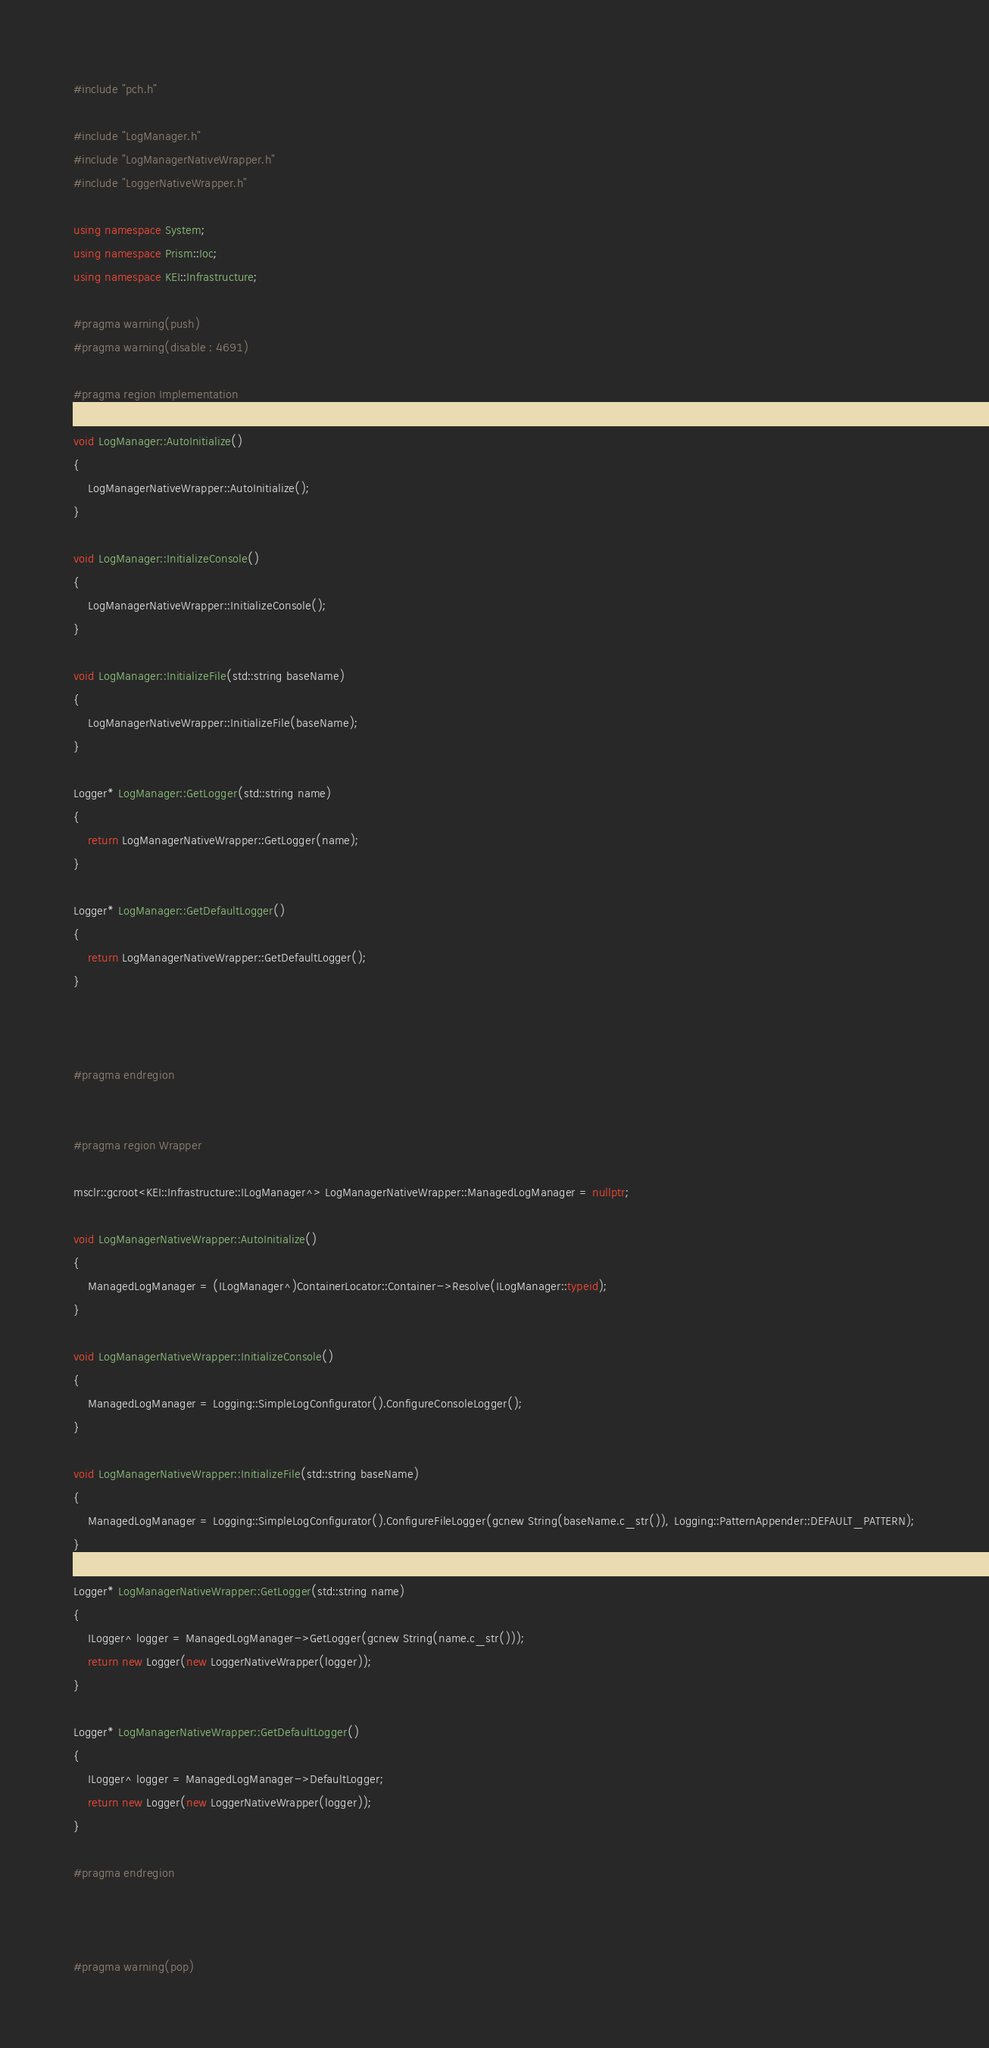Convert code to text. <code><loc_0><loc_0><loc_500><loc_500><_C++_>#include "pch.h"

#include "LogManager.h"
#include "LogManagerNativeWrapper.h"
#include "LoggerNativeWrapper.h"

using namespace System;
using namespace Prism::Ioc;
using namespace KEI::Infrastructure;

#pragma warning(push)
#pragma warning(disable : 4691)

#pragma region Implementation

void LogManager::AutoInitialize()
{
	LogManagerNativeWrapper::AutoInitialize();
}

void LogManager::InitializeConsole()
{
	LogManagerNativeWrapper::InitializeConsole();
}

void LogManager::InitializeFile(std::string baseName)
{
	LogManagerNativeWrapper::InitializeFile(baseName);
}

Logger* LogManager::GetLogger(std::string name)
{
	return LogManagerNativeWrapper::GetLogger(name);
}

Logger* LogManager::GetDefaultLogger()
{
	return LogManagerNativeWrapper::GetDefaultLogger();
}



#pragma endregion


#pragma region Wrapper

msclr::gcroot<KEI::Infrastructure::ILogManager^> LogManagerNativeWrapper::ManagedLogManager = nullptr;

void LogManagerNativeWrapper::AutoInitialize()
{
	ManagedLogManager = (ILogManager^)ContainerLocator::Container->Resolve(ILogManager::typeid);
}

void LogManagerNativeWrapper::InitializeConsole()
{
	ManagedLogManager = Logging::SimpleLogConfigurator().ConfigureConsoleLogger();
}

void LogManagerNativeWrapper::InitializeFile(std::string baseName)
{
	ManagedLogManager = Logging::SimpleLogConfigurator().ConfigureFileLogger(gcnew String(baseName.c_str()), Logging::PatternAppender::DEFAULT_PATTERN);
}

Logger* LogManagerNativeWrapper::GetLogger(std::string name)
{
	ILogger^ logger = ManagedLogManager->GetLogger(gcnew String(name.c_str()));
	return new Logger(new LoggerNativeWrapper(logger));
}

Logger* LogManagerNativeWrapper::GetDefaultLogger()
{
	ILogger^ logger = ManagedLogManager->DefaultLogger;
	return new Logger(new LoggerNativeWrapper(logger));
}

#pragma endregion



#pragma warning(pop)</code> 